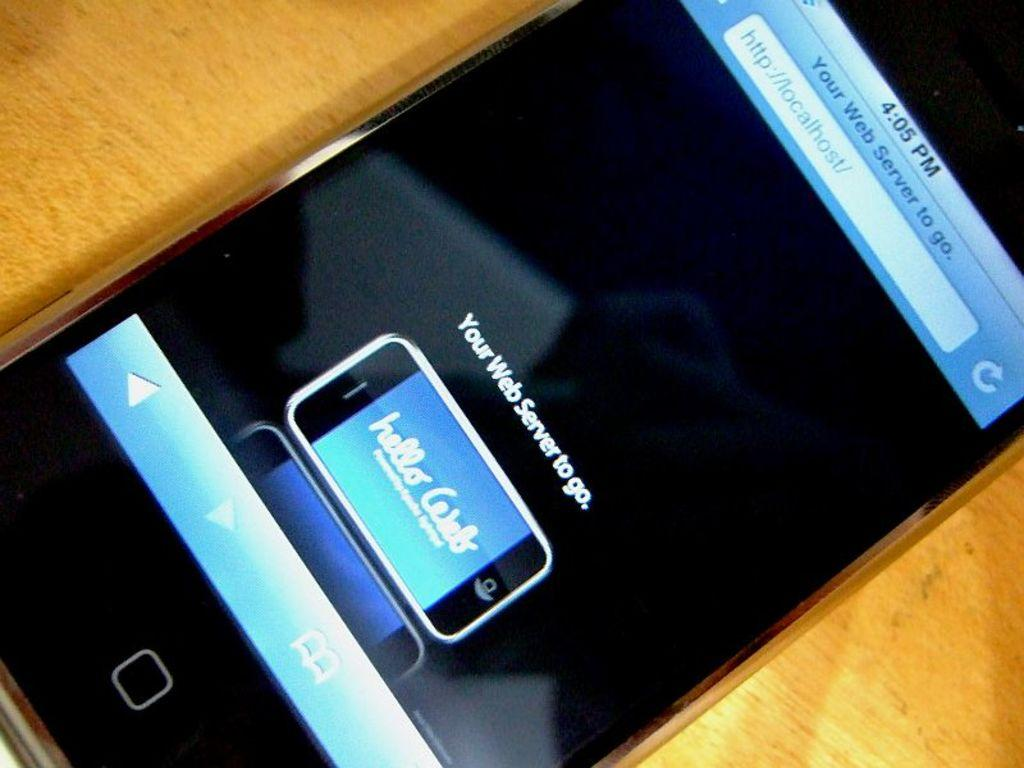<image>
Offer a succinct explanation of the picture presented. A smart phone greets it's owner with the displayed text of "Hello Caleb". 